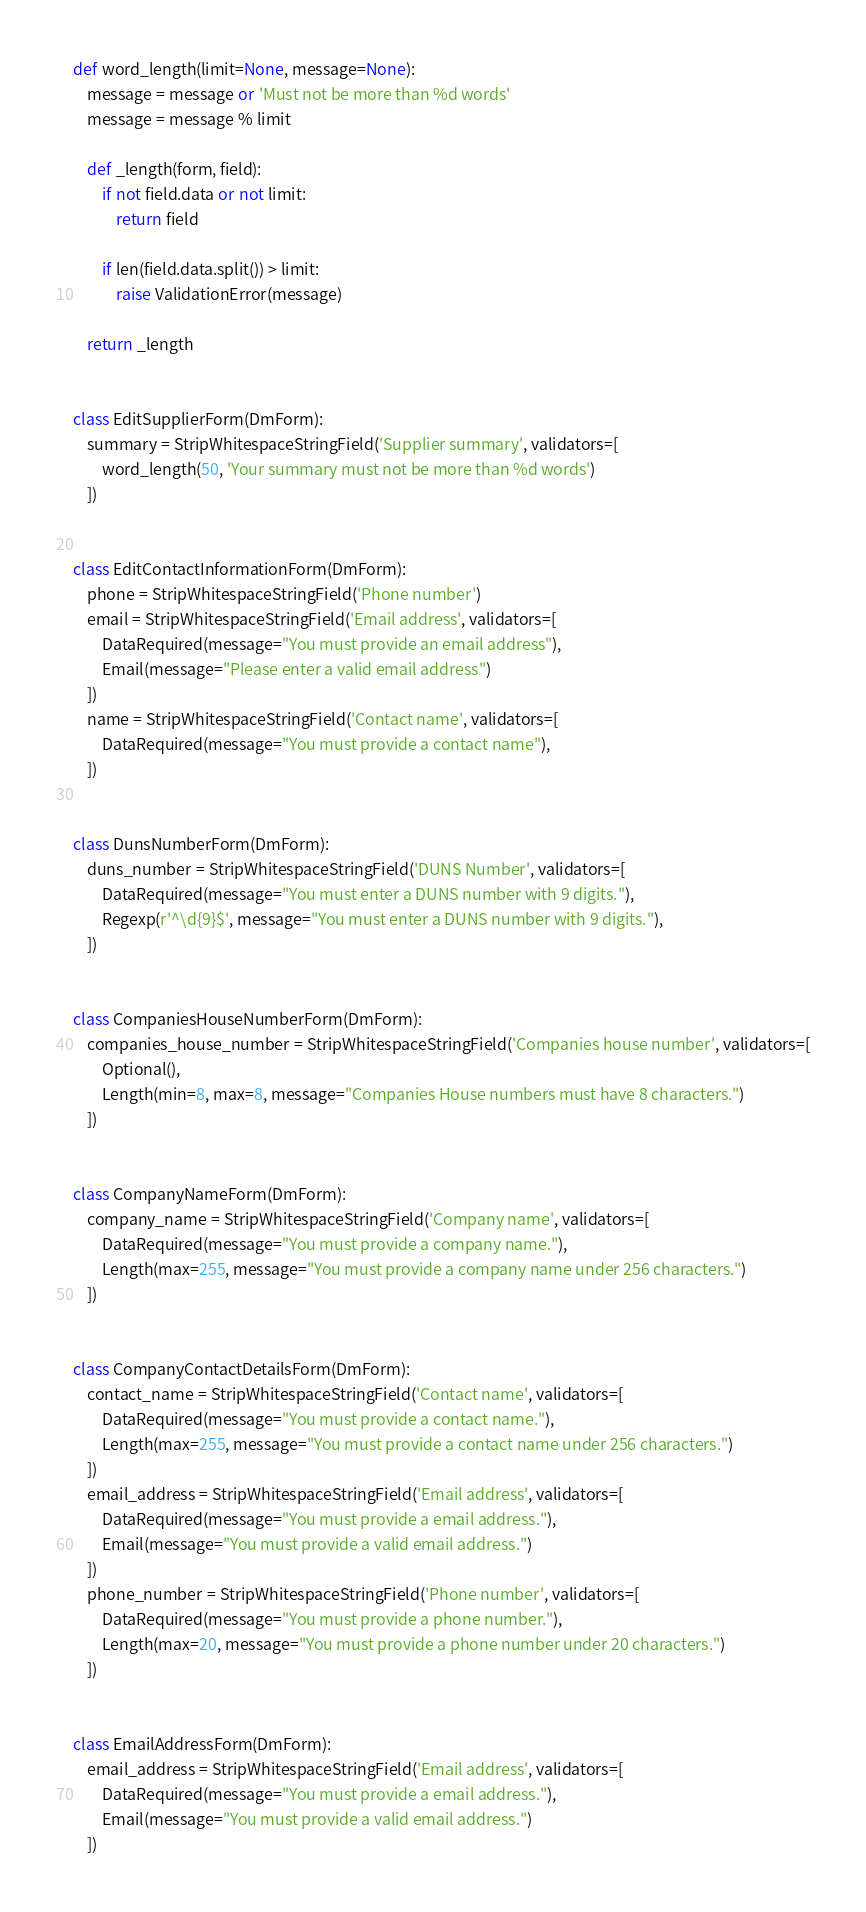Convert code to text. <code><loc_0><loc_0><loc_500><loc_500><_Python_>
def word_length(limit=None, message=None):
    message = message or 'Must not be more than %d words'
    message = message % limit

    def _length(form, field):
        if not field.data or not limit:
            return field

        if len(field.data.split()) > limit:
            raise ValidationError(message)

    return _length


class EditSupplierForm(DmForm):
    summary = StripWhitespaceStringField('Supplier summary', validators=[
        word_length(50, 'Your summary must not be more than %d words')
    ])


class EditContactInformationForm(DmForm):
    phone = StripWhitespaceStringField('Phone number')
    email = StripWhitespaceStringField('Email address', validators=[
        DataRequired(message="You must provide an email address"),
        Email(message="Please enter a valid email address")
    ])
    name = StripWhitespaceStringField('Contact name', validators=[
        DataRequired(message="You must provide a contact name"),
    ])


class DunsNumberForm(DmForm):
    duns_number = StripWhitespaceStringField('DUNS Number', validators=[
        DataRequired(message="You must enter a DUNS number with 9 digits."),
        Regexp(r'^\d{9}$', message="You must enter a DUNS number with 9 digits."),
    ])


class CompaniesHouseNumberForm(DmForm):
    companies_house_number = StripWhitespaceStringField('Companies house number', validators=[
        Optional(),
        Length(min=8, max=8, message="Companies House numbers must have 8 characters.")
    ])


class CompanyNameForm(DmForm):
    company_name = StripWhitespaceStringField('Company name', validators=[
        DataRequired(message="You must provide a company name."),
        Length(max=255, message="You must provide a company name under 256 characters.")
    ])


class CompanyContactDetailsForm(DmForm):
    contact_name = StripWhitespaceStringField('Contact name', validators=[
        DataRequired(message="You must provide a contact name."),
        Length(max=255, message="You must provide a contact name under 256 characters.")
    ])
    email_address = StripWhitespaceStringField('Email address', validators=[
        DataRequired(message="You must provide a email address."),
        Email(message="You must provide a valid email address.")
    ])
    phone_number = StripWhitespaceStringField('Phone number', validators=[
        DataRequired(message="You must provide a phone number."),
        Length(max=20, message="You must provide a phone number under 20 characters.")
    ])


class EmailAddressForm(DmForm):
    email_address = StripWhitespaceStringField('Email address', validators=[
        DataRequired(message="You must provide a email address."),
        Email(message="You must provide a valid email address.")
    ])
</code> 